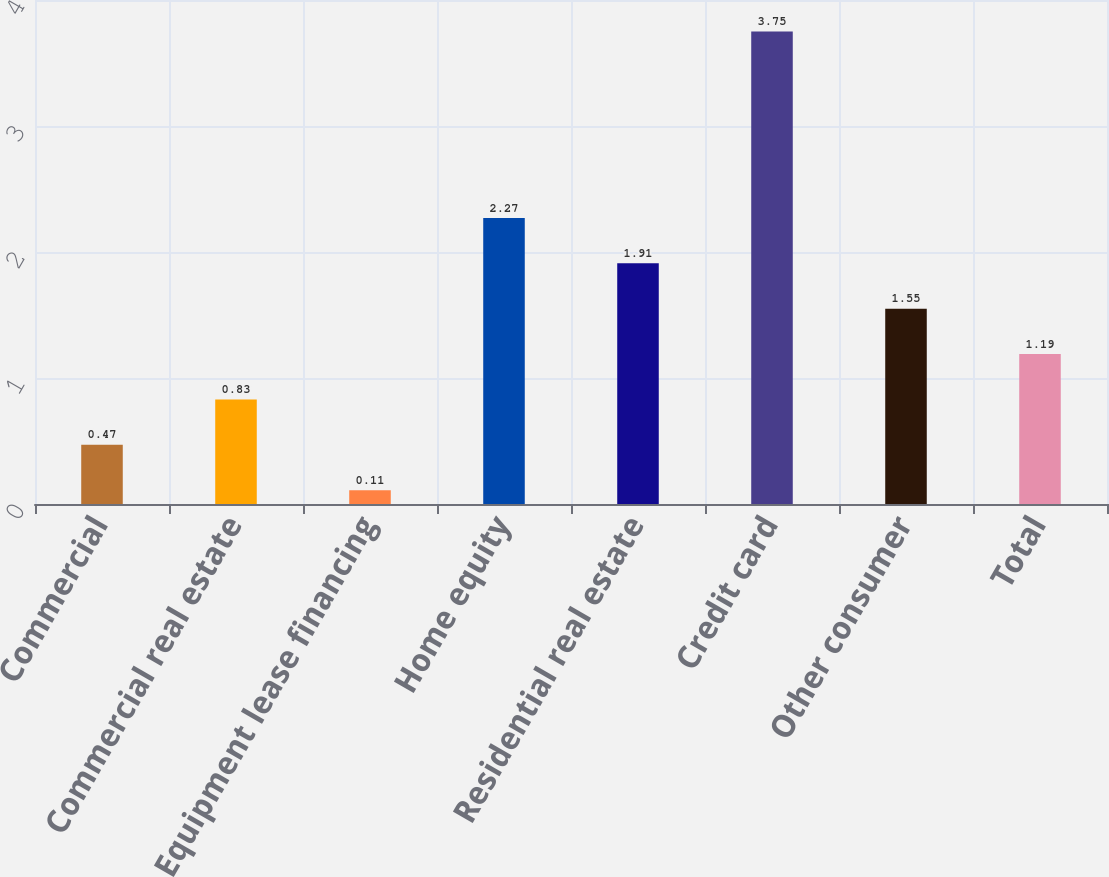Convert chart. <chart><loc_0><loc_0><loc_500><loc_500><bar_chart><fcel>Commercial<fcel>Commercial real estate<fcel>Equipment lease financing<fcel>Home equity<fcel>Residential real estate<fcel>Credit card<fcel>Other consumer<fcel>Total<nl><fcel>0.47<fcel>0.83<fcel>0.11<fcel>2.27<fcel>1.91<fcel>3.75<fcel>1.55<fcel>1.19<nl></chart> 